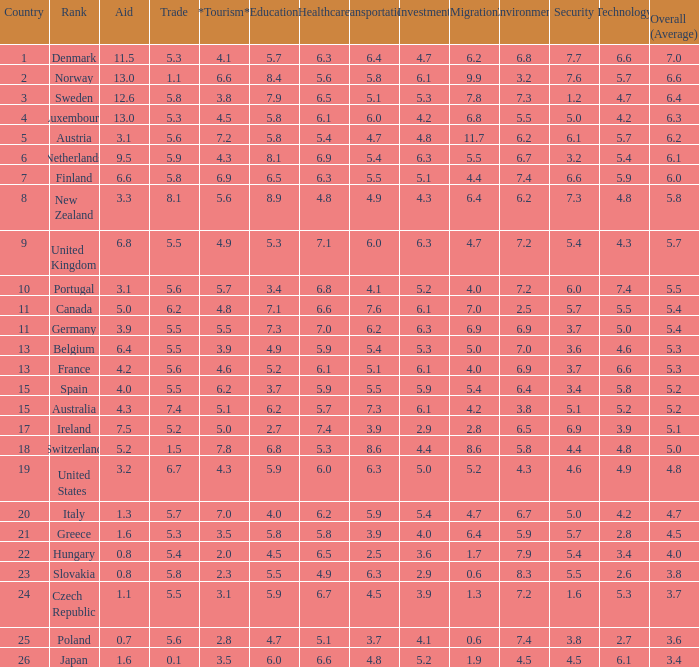What country has a 5.5 mark for security? Slovakia. 